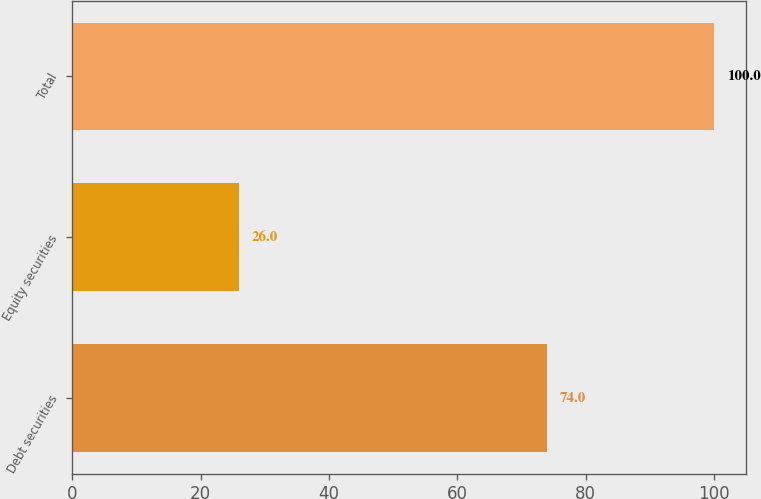<chart> <loc_0><loc_0><loc_500><loc_500><bar_chart><fcel>Debt securities<fcel>Equity securities<fcel>Total<nl><fcel>74<fcel>26<fcel>100<nl></chart> 